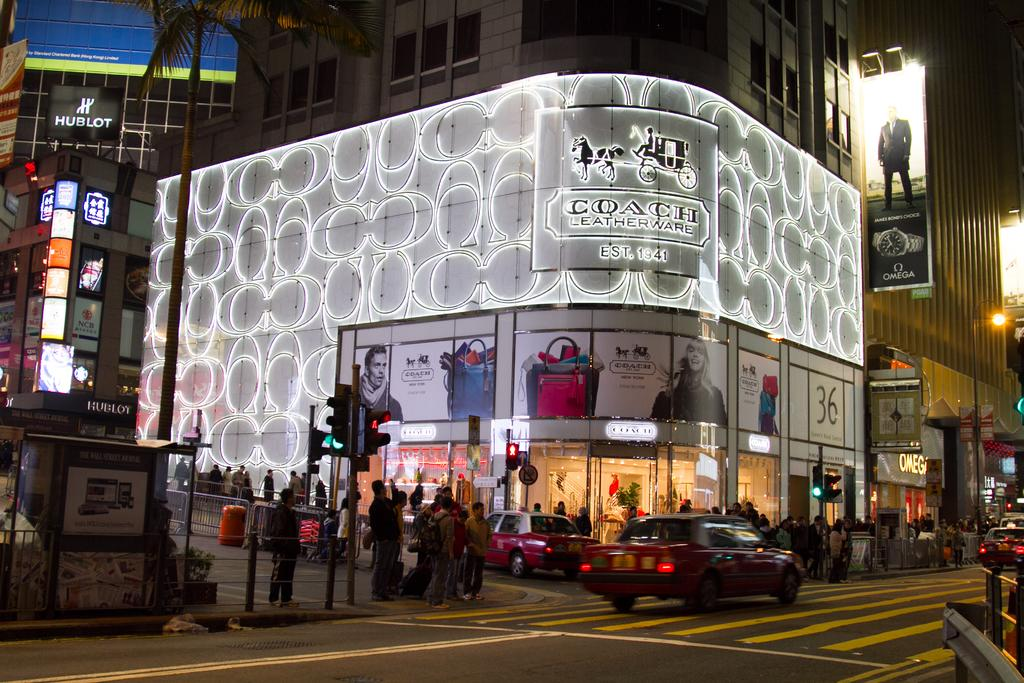<image>
Share a concise interpretation of the image provided. a Leatherware store that has a sign outside at night 